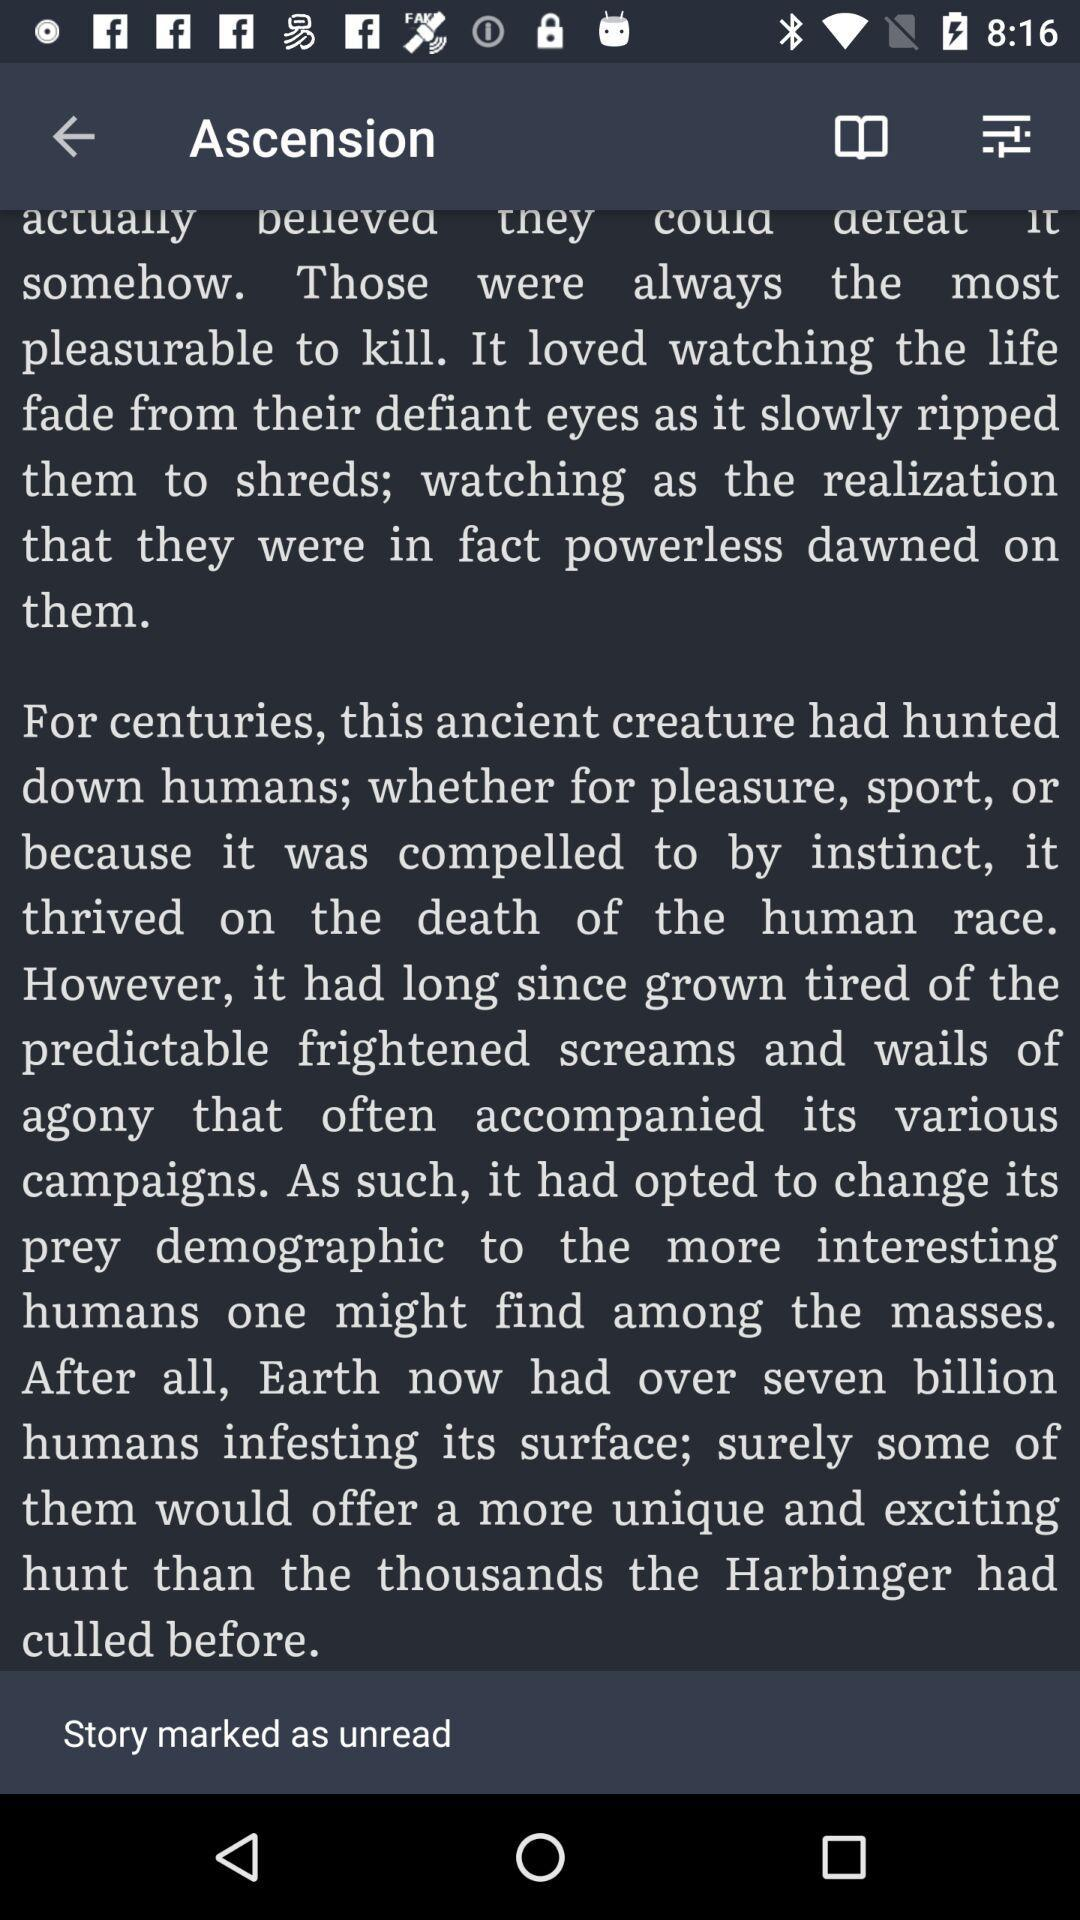How many unread stories are there?
Answer the question using a single word or phrase. 1 